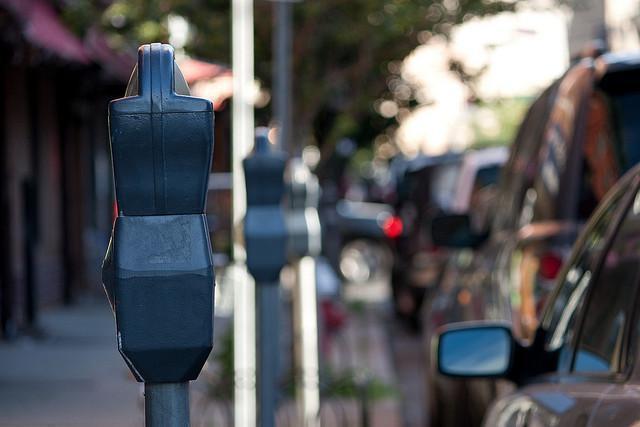What is to the left of the cars?
From the following set of four choices, select the accurate answer to respond to the question.
Options: Dog, bicycles, parking meters, cats. Parking meters. 